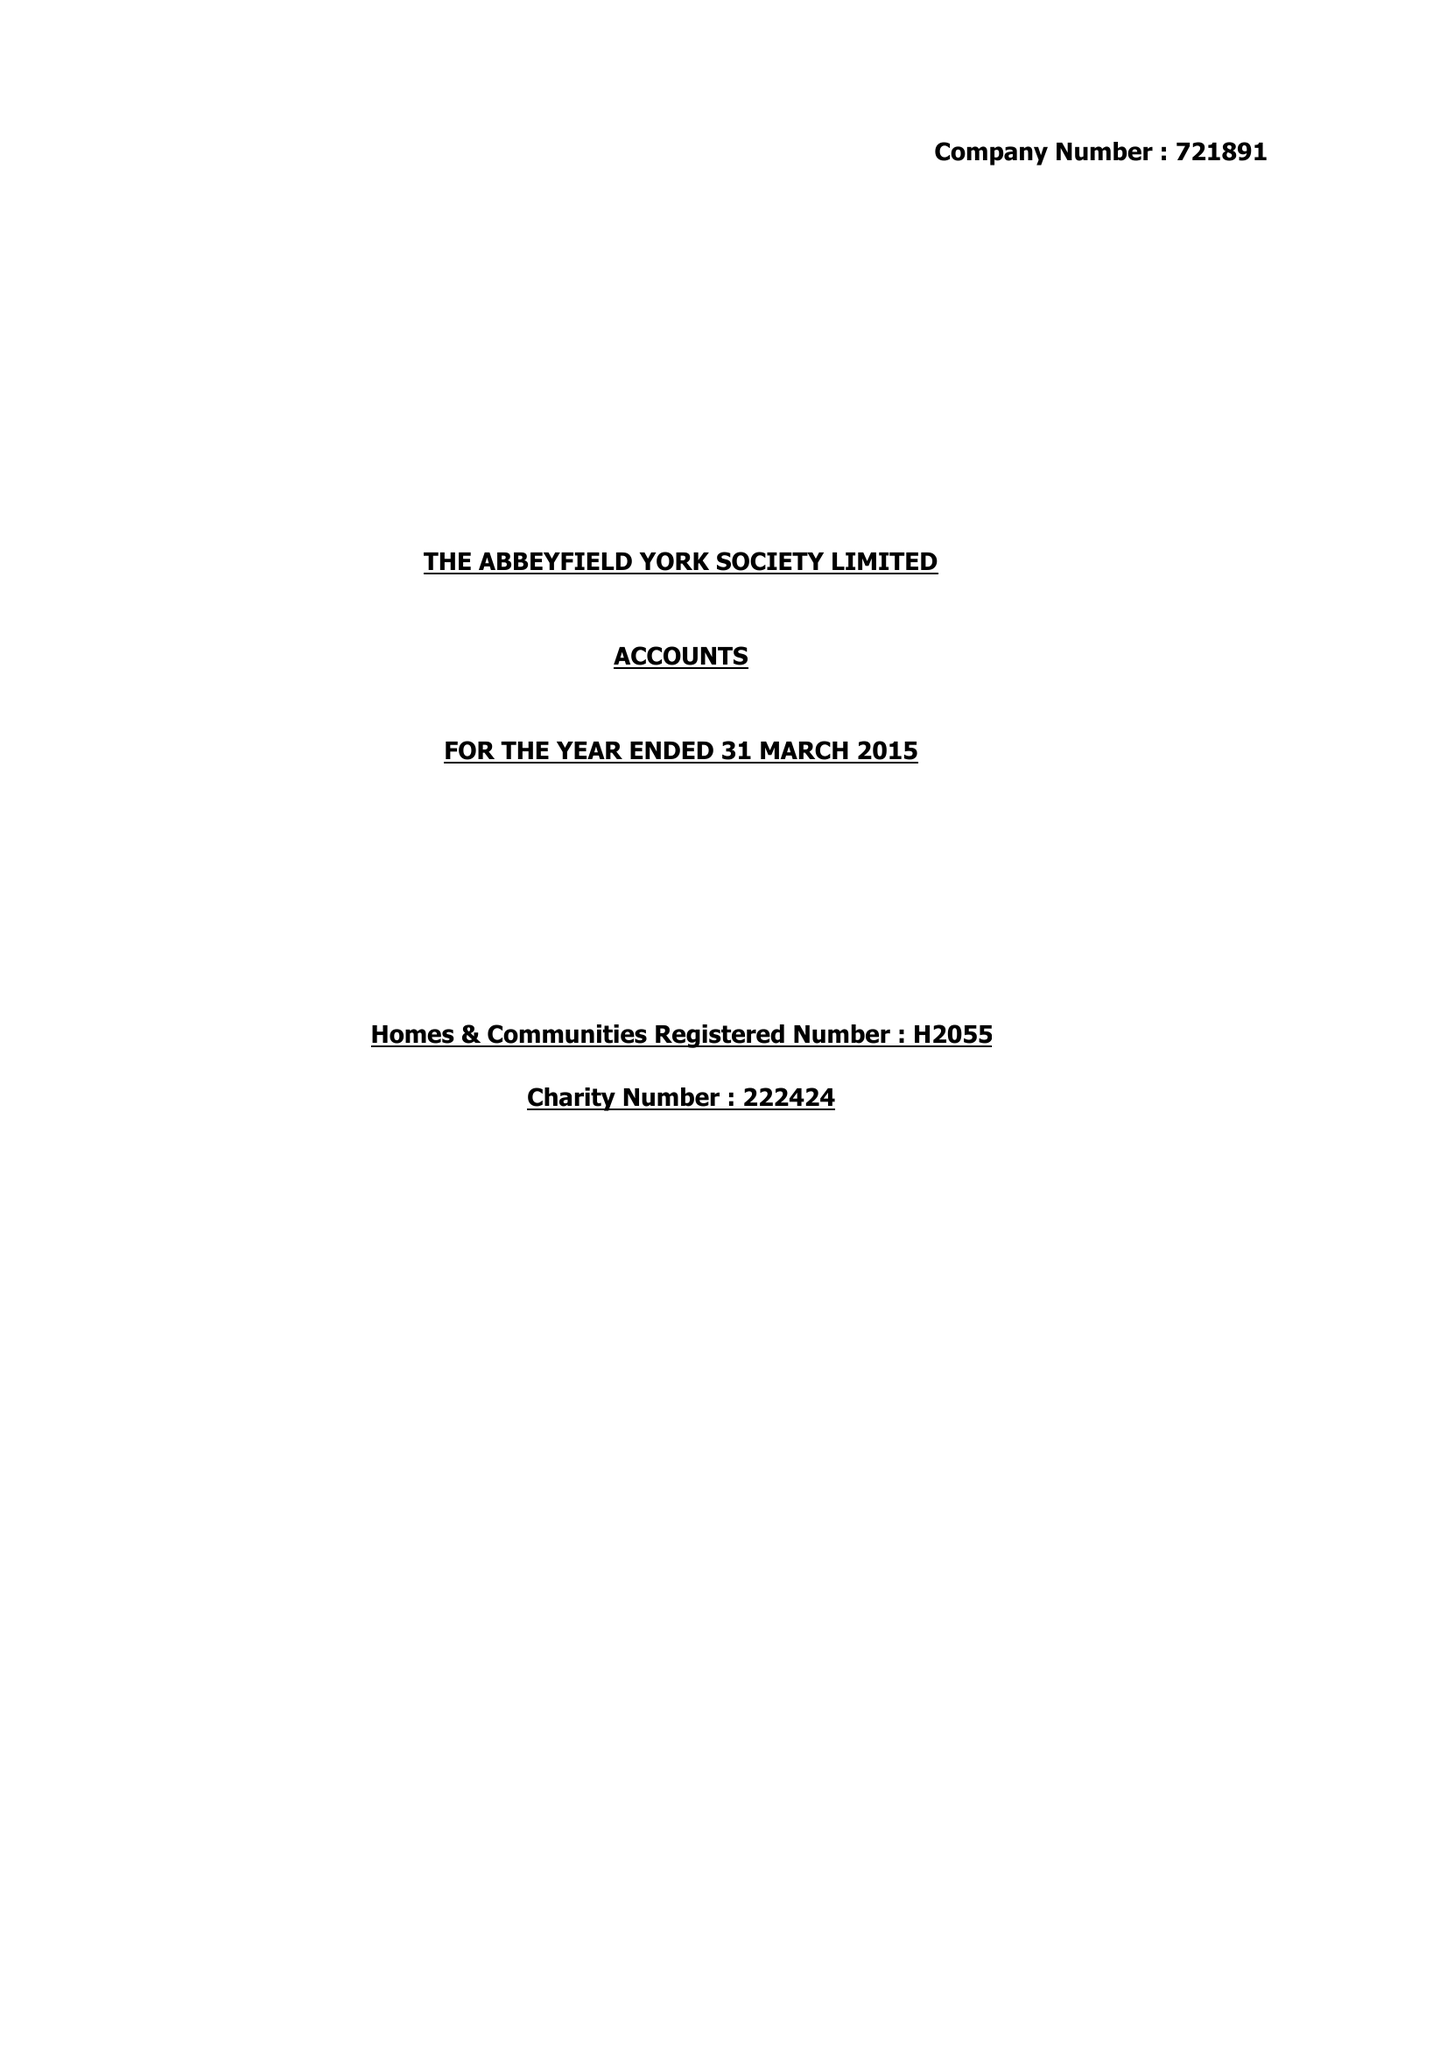What is the value for the income_annually_in_british_pounds?
Answer the question using a single word or phrase. 442106.00 